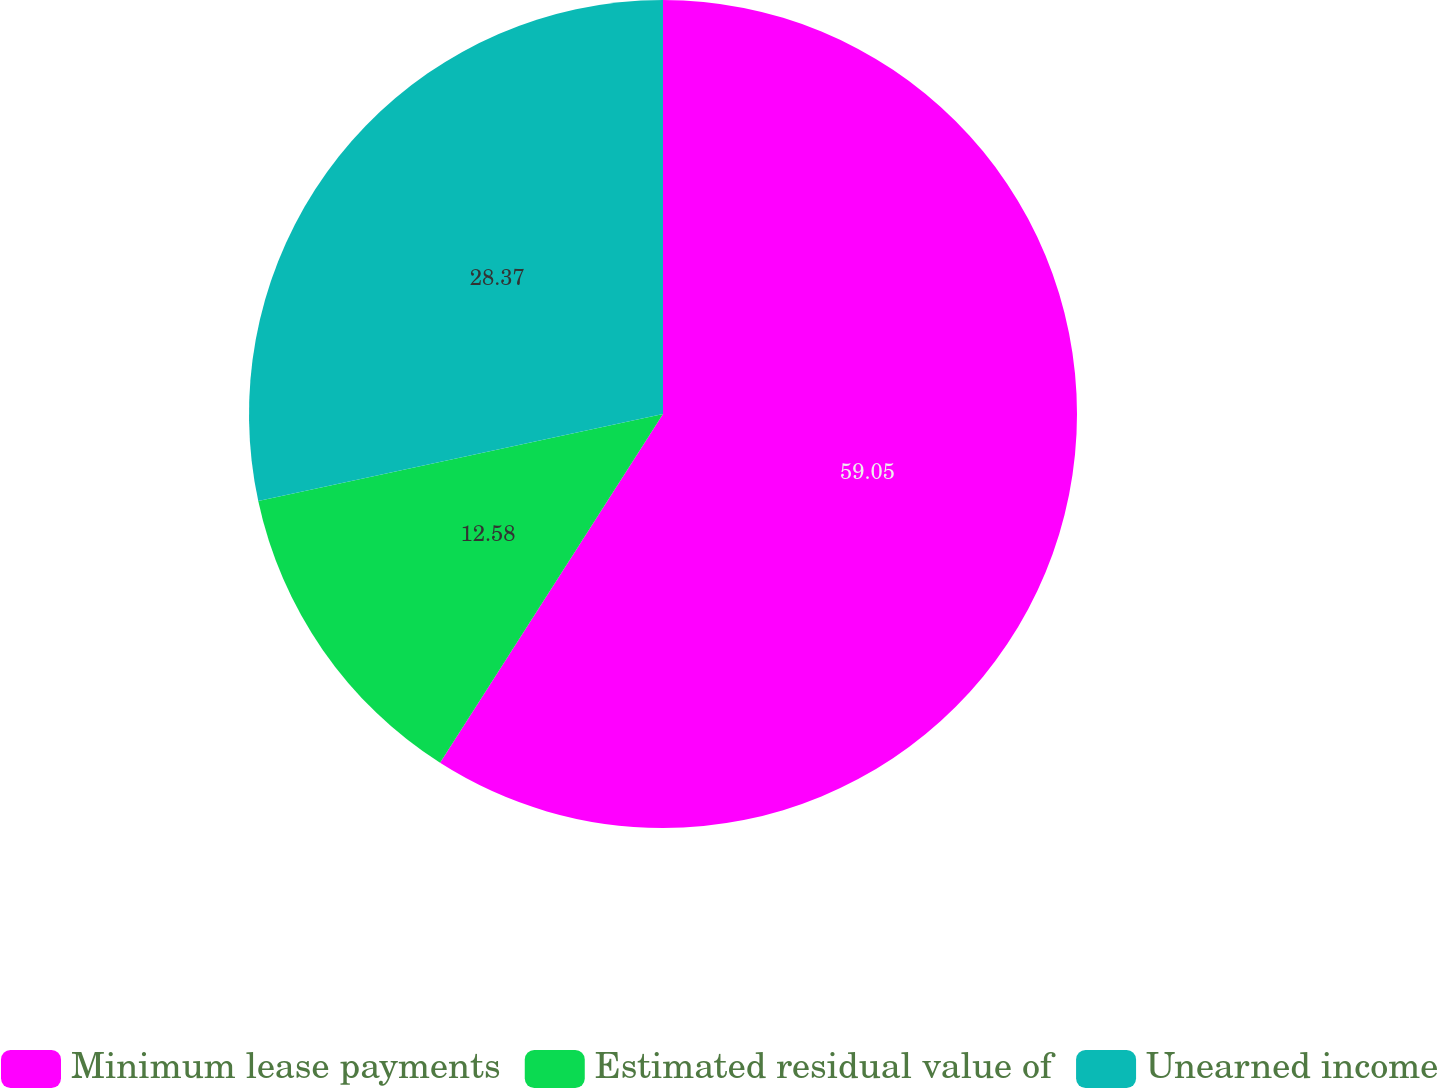Convert chart to OTSL. <chart><loc_0><loc_0><loc_500><loc_500><pie_chart><fcel>Minimum lease payments<fcel>Estimated residual value of<fcel>Unearned income<nl><fcel>59.05%<fcel>12.58%<fcel>28.37%<nl></chart> 